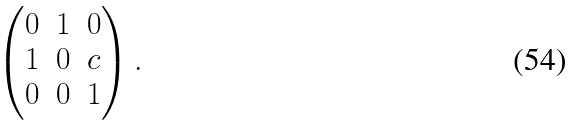Convert formula to latex. <formula><loc_0><loc_0><loc_500><loc_500>\begin{pmatrix} 0 & 1 & 0 \\ 1 & 0 & c \\ 0 & 0 & 1 \end{pmatrix} .</formula> 